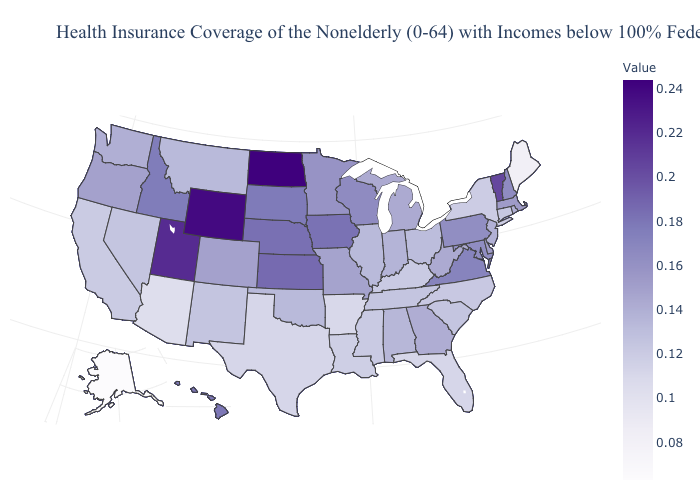Does Illinois have the highest value in the USA?
Short answer required. No. Does Arkansas have the highest value in the USA?
Give a very brief answer. No. Does the map have missing data?
Be succinct. No. Is the legend a continuous bar?
Keep it brief. Yes. Does North Dakota have the lowest value in the MidWest?
Short answer required. No. Among the states that border Iowa , which have the lowest value?
Concise answer only. Illinois. Does the map have missing data?
Be succinct. No. 